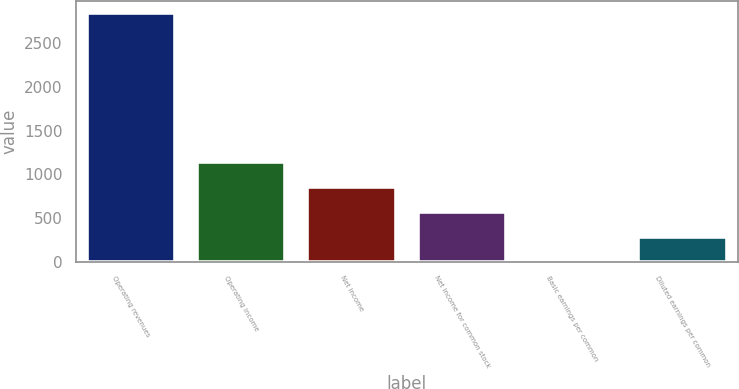Convert chart. <chart><loc_0><loc_0><loc_500><loc_500><bar_chart><fcel>Operating revenues<fcel>Operating income<fcel>Net income<fcel>Net income for common stock<fcel>Basic earnings per common<fcel>Diluted earnings per common<nl><fcel>2845<fcel>1138.33<fcel>853.88<fcel>569.44<fcel>0.55<fcel>285<nl></chart> 